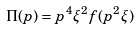Convert formula to latex. <formula><loc_0><loc_0><loc_500><loc_500>\Pi ( p ) = p ^ { 4 } \xi ^ { 2 } f ( p ^ { 2 } \xi )</formula> 